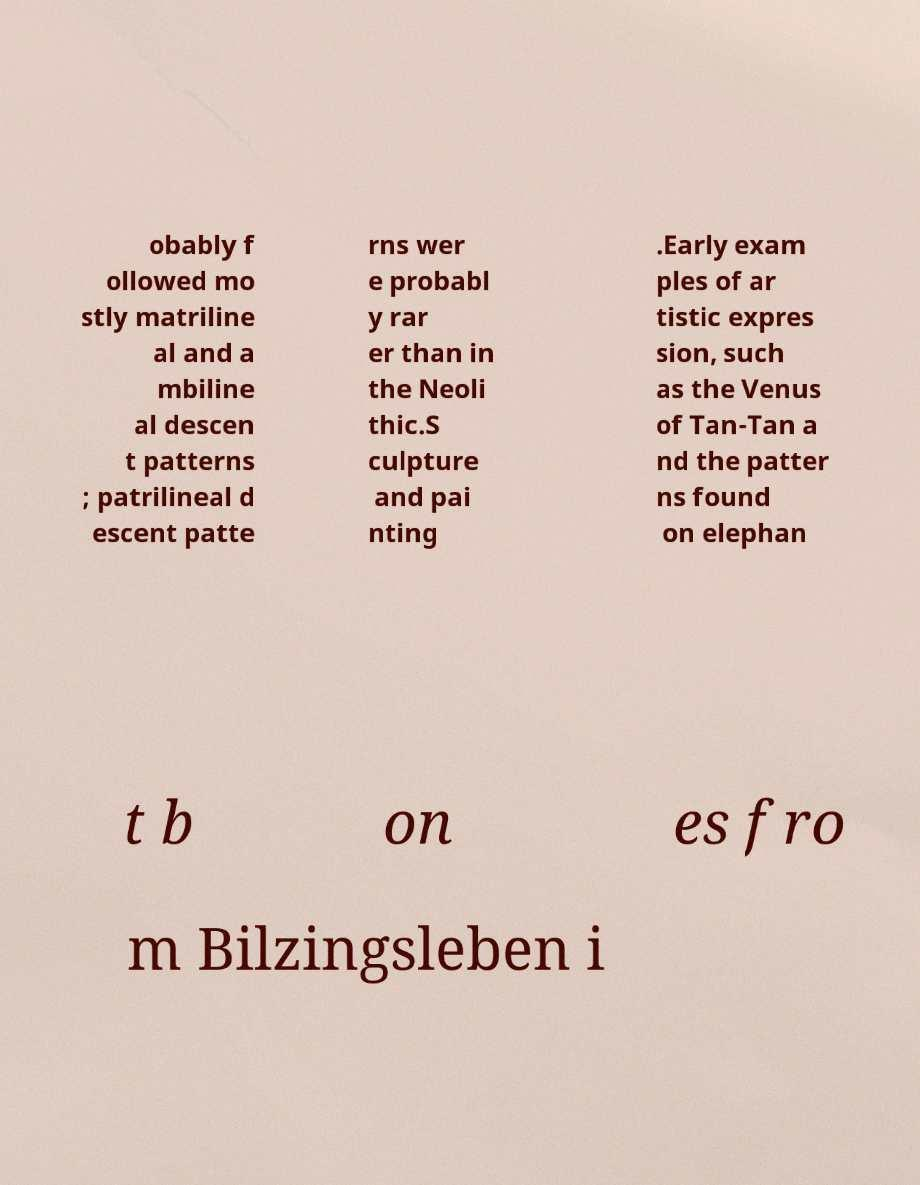Can you accurately transcribe the text from the provided image for me? obably f ollowed mo stly matriline al and a mbiline al descen t patterns ; patrilineal d escent patte rns wer e probabl y rar er than in the Neoli thic.S culpture and pai nting .Early exam ples of ar tistic expres sion, such as the Venus of Tan-Tan a nd the patter ns found on elephan t b on es fro m Bilzingsleben i 